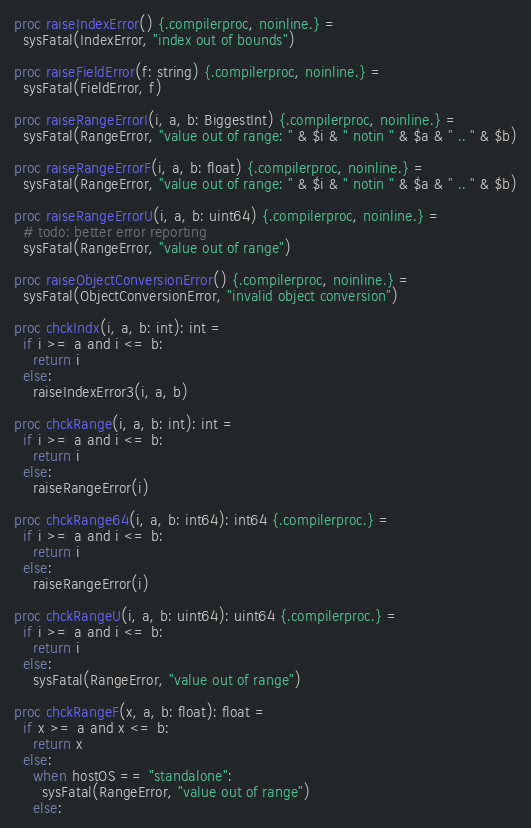Convert code to text. <code><loc_0><loc_0><loc_500><loc_500><_Nim_>
proc raiseIndexError() {.compilerproc, noinline.} =
  sysFatal(IndexError, "index out of bounds")

proc raiseFieldError(f: string) {.compilerproc, noinline.} =
  sysFatal(FieldError, f)

proc raiseRangeErrorI(i, a, b: BiggestInt) {.compilerproc, noinline.} =
  sysFatal(RangeError, "value out of range: " & $i & " notin " & $a & " .. " & $b)

proc raiseRangeErrorF(i, a, b: float) {.compilerproc, noinline.} =
  sysFatal(RangeError, "value out of range: " & $i & " notin " & $a & " .. " & $b)

proc raiseRangeErrorU(i, a, b: uint64) {.compilerproc, noinline.} =
  # todo: better error reporting
  sysFatal(RangeError, "value out of range")

proc raiseObjectConversionError() {.compilerproc, noinline.} =
  sysFatal(ObjectConversionError, "invalid object conversion")

proc chckIndx(i, a, b: int): int =
  if i >= a and i <= b:
    return i
  else:
    raiseIndexError3(i, a, b)

proc chckRange(i, a, b: int): int =
  if i >= a and i <= b:
    return i
  else:
    raiseRangeError(i)

proc chckRange64(i, a, b: int64): int64 {.compilerproc.} =
  if i >= a and i <= b:
    return i
  else:
    raiseRangeError(i)

proc chckRangeU(i, a, b: uint64): uint64 {.compilerproc.} =
  if i >= a and i <= b:
    return i
  else:
    sysFatal(RangeError, "value out of range")

proc chckRangeF(x, a, b: float): float =
  if x >= a and x <= b:
    return x
  else:
    when hostOS == "standalone":
      sysFatal(RangeError, "value out of range")
    else:</code> 